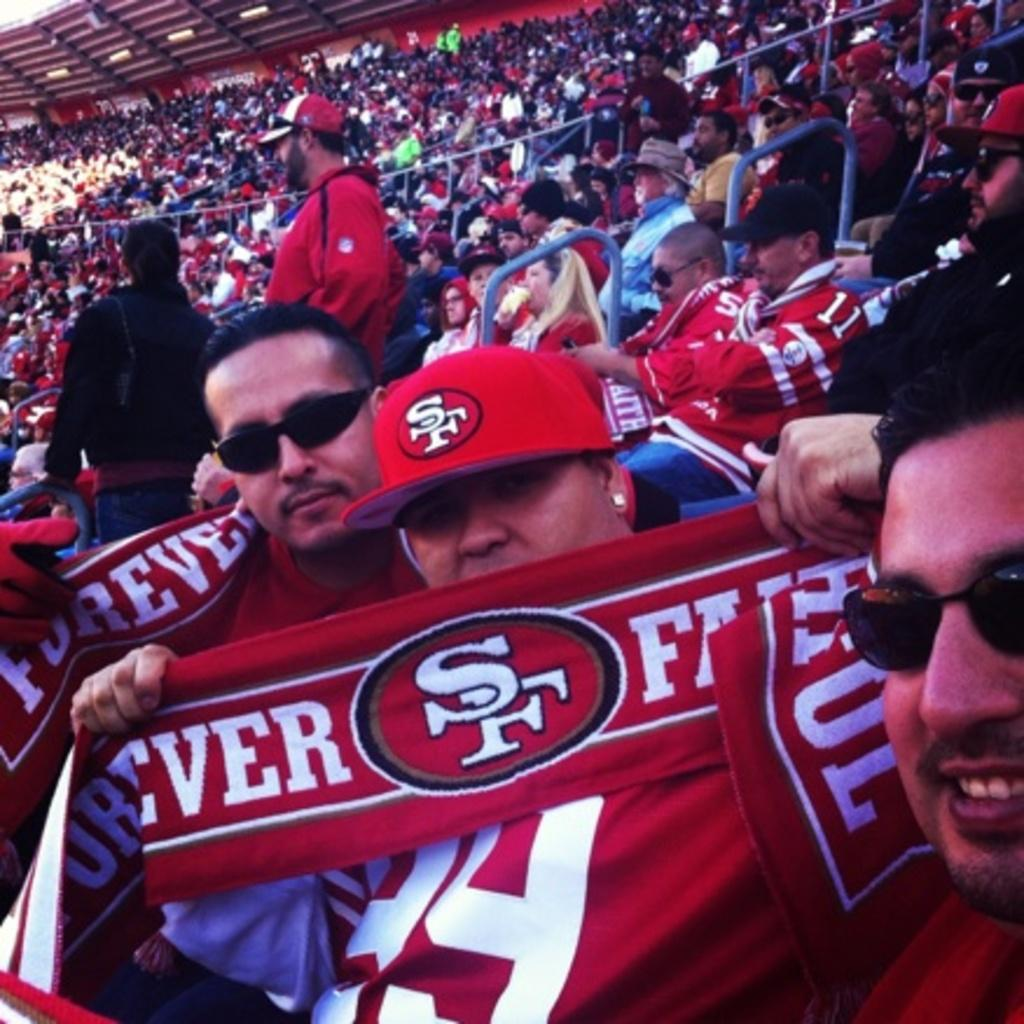<image>
Describe the image concisely. a person that has an SF flag at a game 